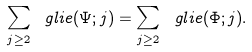<formula> <loc_0><loc_0><loc_500><loc_500>\sum _ { j \geq 2 } \ g l i e ( \Psi ; j ) = \sum _ { j \geq 2 } \ g l i e ( \Phi ; j ) .</formula> 